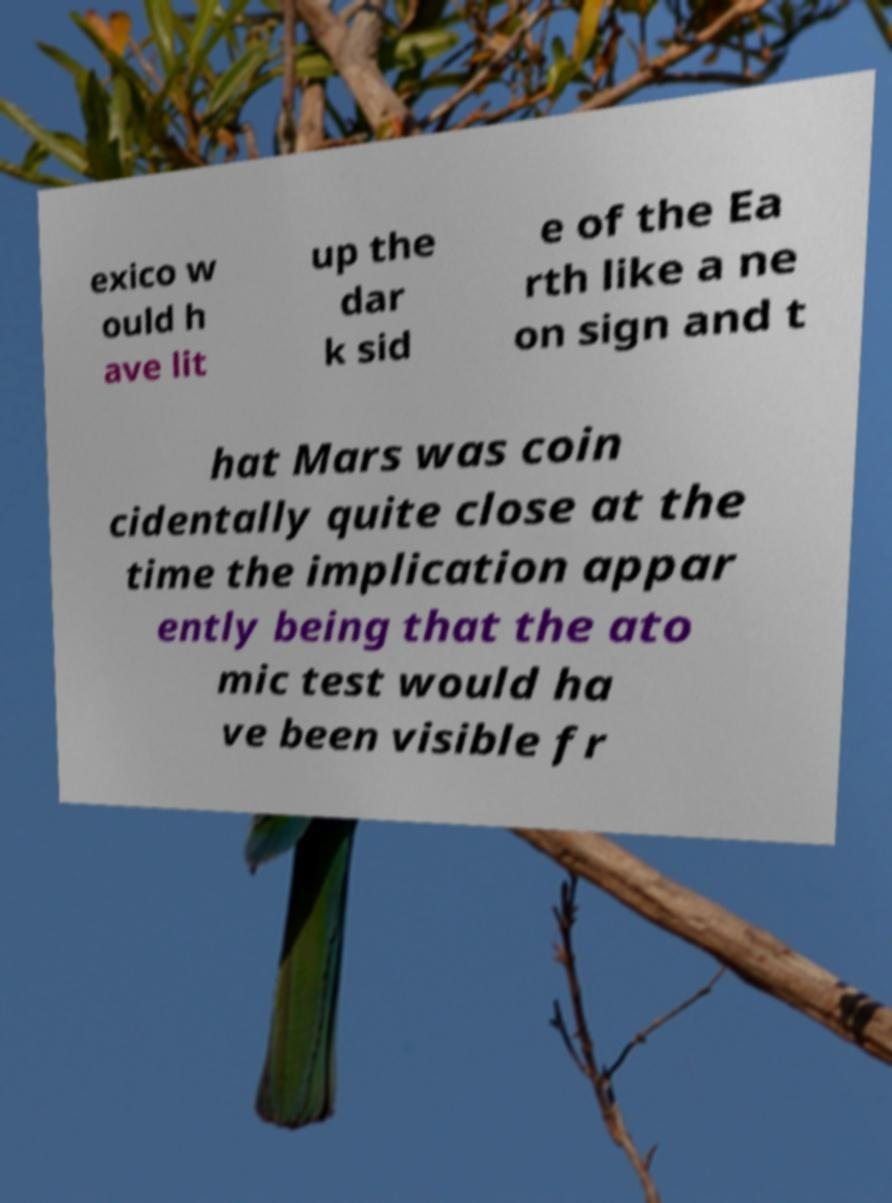Please identify and transcribe the text found in this image. exico w ould h ave lit up the dar k sid e of the Ea rth like a ne on sign and t hat Mars was coin cidentally quite close at the time the implication appar ently being that the ato mic test would ha ve been visible fr 